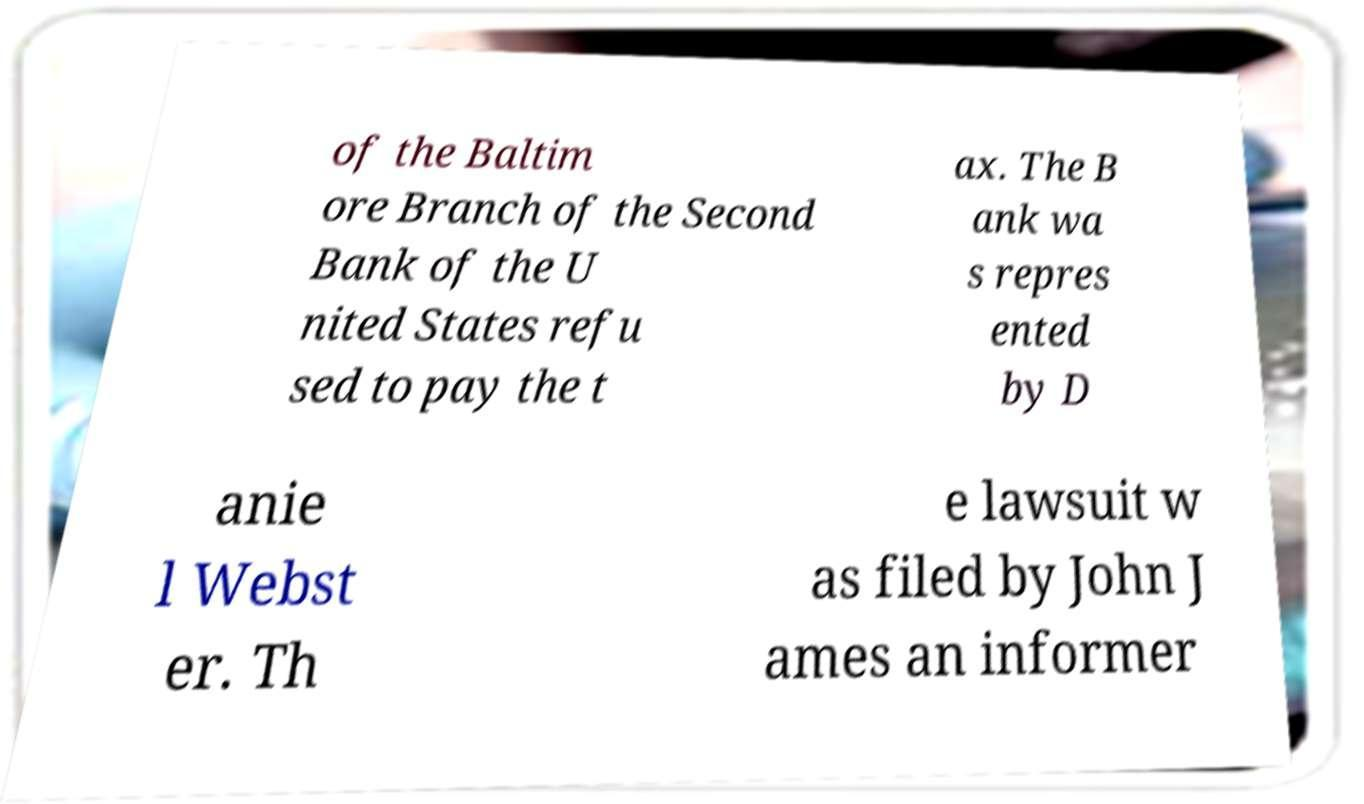Can you read and provide the text displayed in the image?This photo seems to have some interesting text. Can you extract and type it out for me? of the Baltim ore Branch of the Second Bank of the U nited States refu sed to pay the t ax. The B ank wa s repres ented by D anie l Webst er. Th e lawsuit w as filed by John J ames an informer 